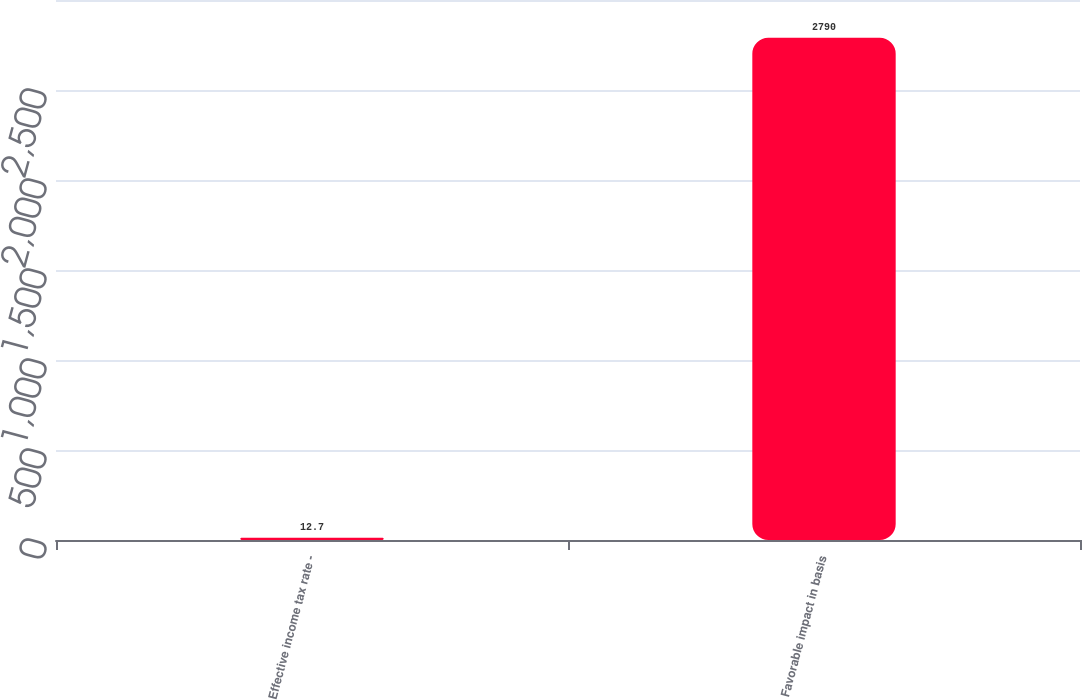Convert chart. <chart><loc_0><loc_0><loc_500><loc_500><bar_chart><fcel>Effective income tax rate -<fcel>Favorable impact in basis<nl><fcel>12.7<fcel>2790<nl></chart> 